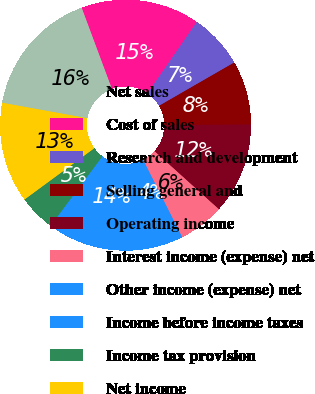<chart> <loc_0><loc_0><loc_500><loc_500><pie_chart><fcel>Net sales<fcel>Cost of sales<fcel>Research and development<fcel>Selling general and<fcel>Operating income<fcel>Interest income (expense) net<fcel>Other income (expense) net<fcel>Income before income taxes<fcel>Income tax provision<fcel>Net income<nl><fcel>16.47%<fcel>15.29%<fcel>7.06%<fcel>8.24%<fcel>11.76%<fcel>5.88%<fcel>3.53%<fcel>14.12%<fcel>4.71%<fcel>12.94%<nl></chart> 